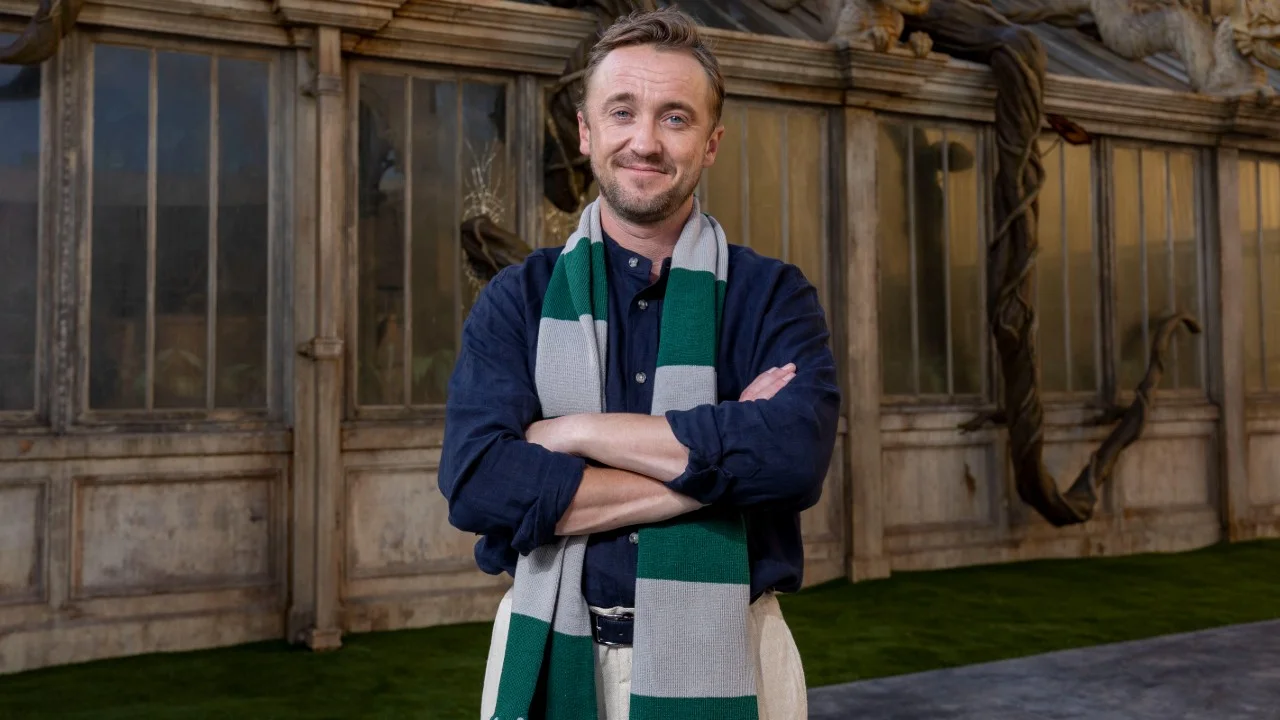Analyze the image in a comprehensive and detailed manner. In the image, an individual stands confidently with arms crossed in front of a large window. He is dressed in a blue shirt and wears a green and white scarf. The relaxed and composed expression on his face, accented by a slight smile, exudes a calm and reflective demeanor. Behind him, the setting features rustic stone walls, suggestive of a historic or architecturally rich environment. Elements such as the weathered wood and large windows add depth to the scene, blending seamlessly with the subject's poised and introspective stance. The backdrop is also adorned with coiling, plant-like structures which lend an air of enchantment and an almost whimsical atmosphere, reminiscent of certain themed settings seen in fantasy genres. 